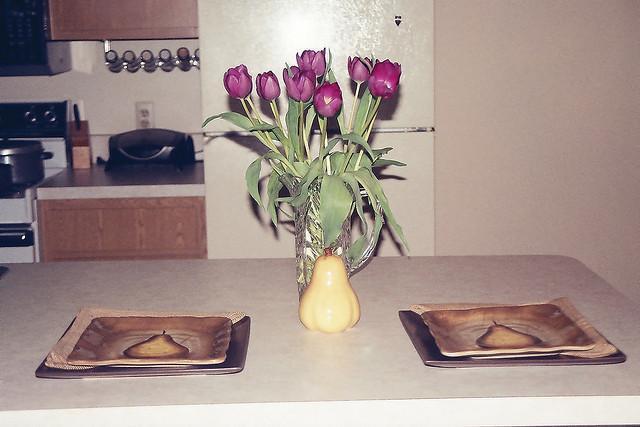How many places are set?
Give a very brief answer. 2. How many flowers are in the vase?
Give a very brief answer. 7. How many toy mice have a sign?
Give a very brief answer. 0. 